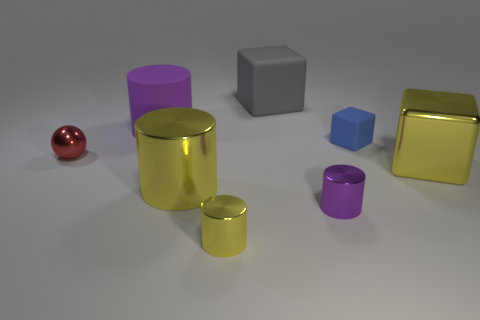The small ball has what color?
Offer a terse response. Red. There is a block that is behind the blue matte object; is its size the same as the purple thing on the right side of the big purple cylinder?
Your answer should be very brief. No. What size is the matte object that is both left of the small purple cylinder and to the right of the large matte cylinder?
Make the answer very short. Large. There is another big object that is the same shape as the large gray object; what color is it?
Your answer should be compact. Yellow. Are there more tiny blue blocks that are in front of the small block than tiny purple objects that are to the left of the gray matte block?
Keep it short and to the point. No. What number of other things are there of the same shape as the small red shiny object?
Keep it short and to the point. 0. There is a small object behind the small red metallic thing; are there any big blocks that are left of it?
Your response must be concise. Yes. What number of metal cylinders are there?
Give a very brief answer. 3. Do the ball and the large metallic object to the left of the yellow metal block have the same color?
Your response must be concise. No. Are there more yellow cylinders than cylinders?
Your answer should be compact. No. 